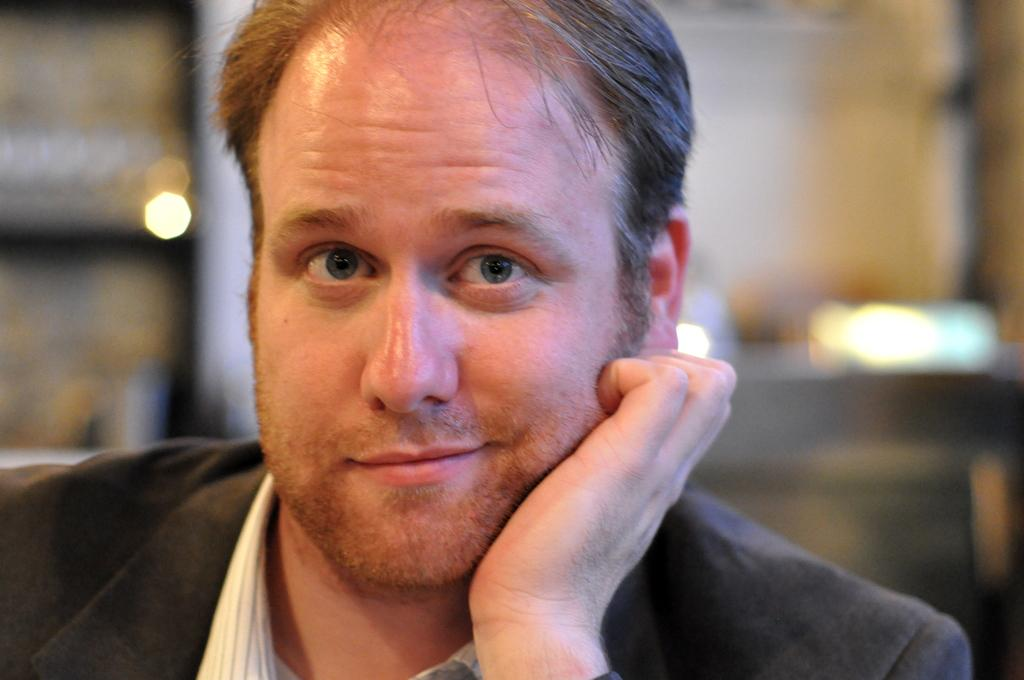What is present in the image? There is a person in the image. What is the person wearing? The person is wearing a black coat. What is the person's facial expression in the image? The person is smiling. What mathematical operation is the person performing in the image? There is no indication in the image that the person is performing any mathematical operation. 